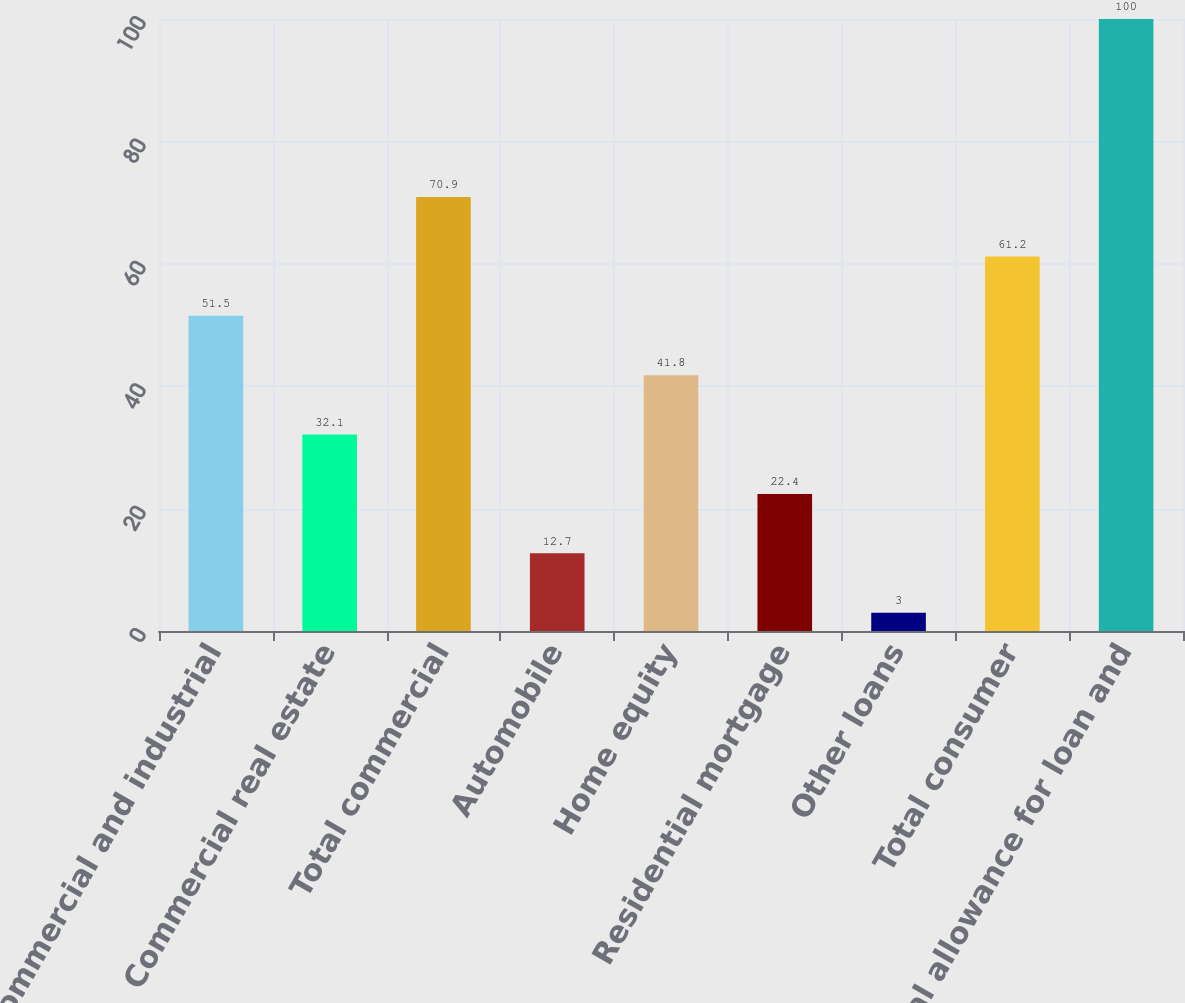<chart> <loc_0><loc_0><loc_500><loc_500><bar_chart><fcel>Commercial and industrial<fcel>Commercial real estate<fcel>Total commercial<fcel>Automobile<fcel>Home equity<fcel>Residential mortgage<fcel>Other loans<fcel>Total consumer<fcel>Total allowance for loan and<nl><fcel>51.5<fcel>32.1<fcel>70.9<fcel>12.7<fcel>41.8<fcel>22.4<fcel>3<fcel>61.2<fcel>100<nl></chart> 